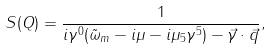<formula> <loc_0><loc_0><loc_500><loc_500>S ( Q ) = \frac { 1 } { i \gamma ^ { 0 } ( \tilde { \omega } _ { m } - i \mu - i \mu _ { 5 } \gamma ^ { 5 } ) - \vec { \gamma } \cdot \vec { q } } ,</formula> 